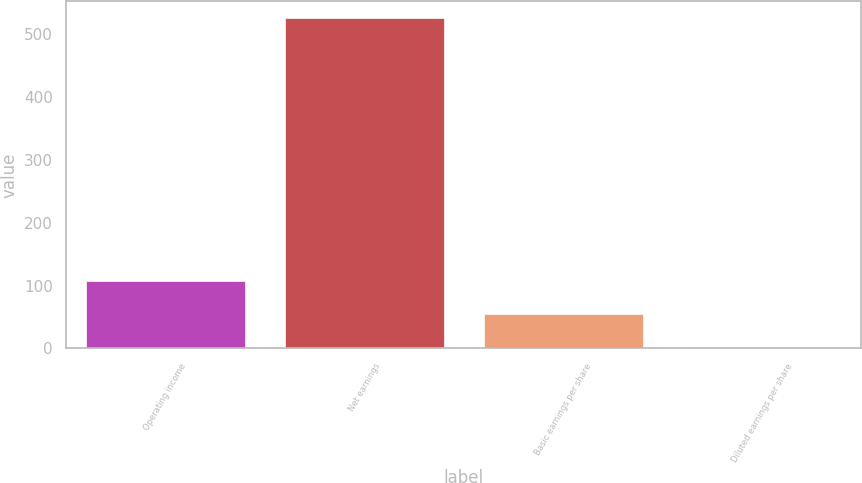Convert chart. <chart><loc_0><loc_0><loc_500><loc_500><bar_chart><fcel>Operating income<fcel>Net earnings<fcel>Basic earnings per share<fcel>Diluted earnings per share<nl><fcel>107.39<fcel>525<fcel>55.19<fcel>2.99<nl></chart> 